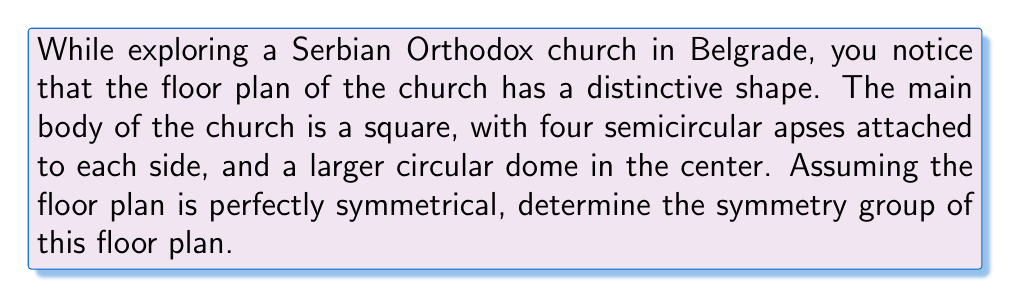Can you answer this question? Let's approach this step-by-step:

1) First, let's visualize the floor plan:

[asy]
unitsize(1cm);
path square = (-2,-2)--(2,-2)--(2,2)--(-2,2)--cycle;
path apse1 = arc((0,2), 1, 0, 180);
path apse2 = arc((2,0), 1, 90, 270);
path apse3 = arc((0,-2), 1, 180, 360);
path apse4 = arc((-2,0), 1, 270, 450);
path dome = Circle((0,0), 1.5);

draw(square);
draw(apse1);
draw(apse2);
draw(apse3);
draw(apse4);
draw(dome);
[/asy]

2) To determine the symmetry group, we need to identify all the symmetry operations that leave the floor plan unchanged.

3) Rotational symmetries:
   - The floor plan is unchanged after rotations of 90°, 180°, 270°, and 360° around the center.
   - This gives us 4-fold rotational symmetry.

4) Reflection symmetries:
   - There are four lines of reflection:
     - Two diagonals of the square
     - Two lines passing through the midpoints of opposite sides of the square

5) The symmetry operations we've identified are:
   - Identity (E)
   - Rotations: 90° (R), 180° (R²), 270° (R³)
   - Reflections: Two diagonal reflections (D₁, D₂) and two axial reflections (H, V)

6) These symmetry operations form a group under composition.

7) This group of symmetries is isomorphic to the dihedral group D₄, which is the symmetry group of a square.

8) The order of this group is 8, as there are 8 distinct symmetry operations.
Answer: $D_4$ 